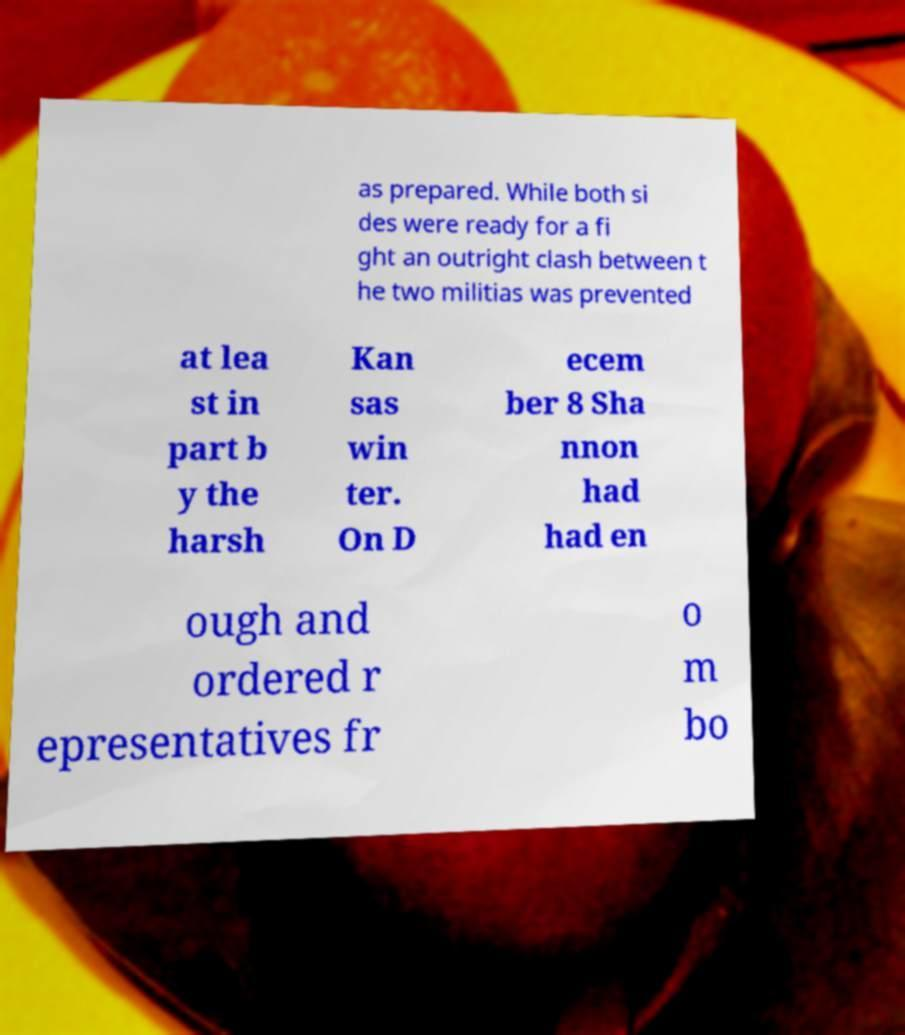Could you assist in decoding the text presented in this image and type it out clearly? as prepared. While both si des were ready for a fi ght an outright clash between t he two militias was prevented at lea st in part b y the harsh Kan sas win ter. On D ecem ber 8 Sha nnon had had en ough and ordered r epresentatives fr o m bo 